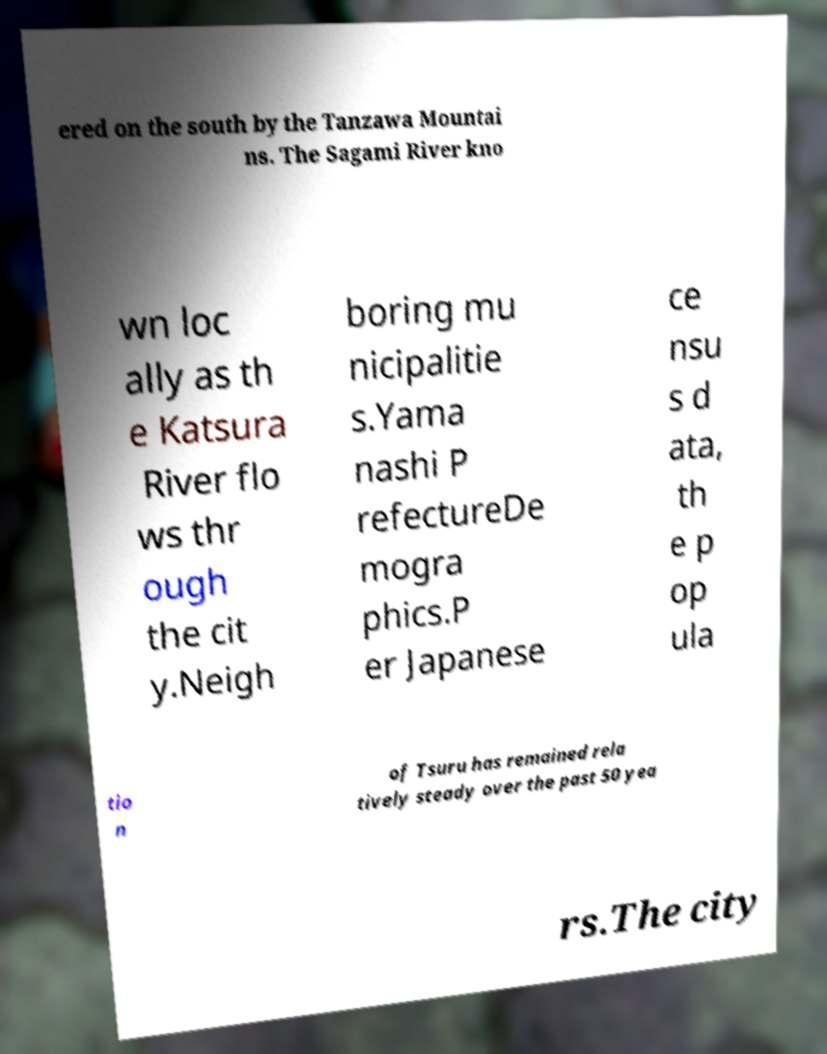I need the written content from this picture converted into text. Can you do that? ered on the south by the Tanzawa Mountai ns. The Sagami River kno wn loc ally as th e Katsura River flo ws thr ough the cit y.Neigh boring mu nicipalitie s.Yama nashi P refectureDe mogra phics.P er Japanese ce nsu s d ata, th e p op ula tio n of Tsuru has remained rela tively steady over the past 50 yea rs.The city 